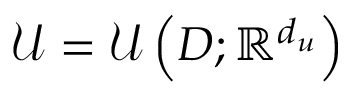<formula> <loc_0><loc_0><loc_500><loc_500>\mathcal { U } = \mathcal { U } \left ( D ; \mathbb { R } ^ { d _ { u } } \right )</formula> 